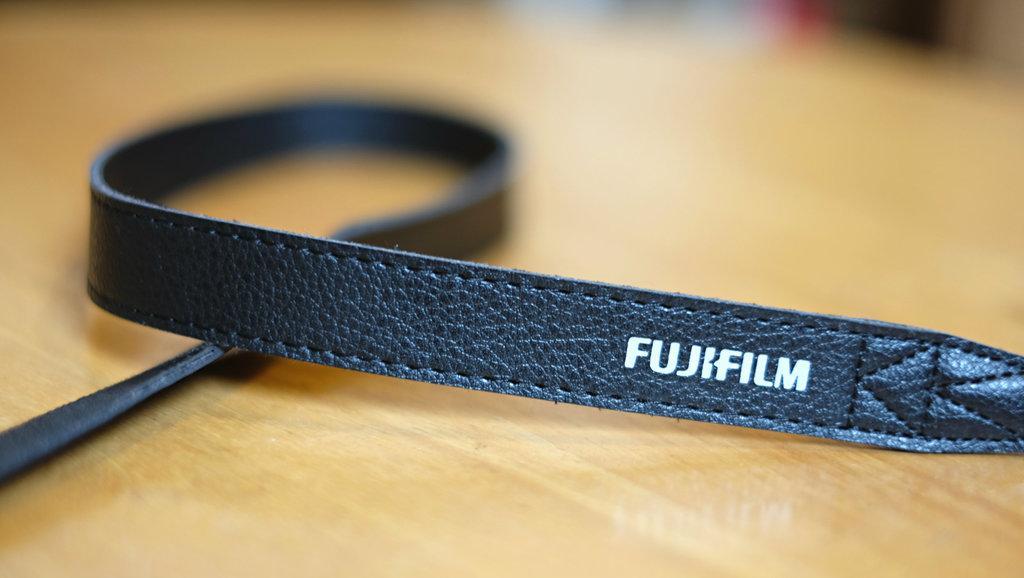Describe this image in one or two sentences. In this picture there is a leather with some text which is placed on the table. 